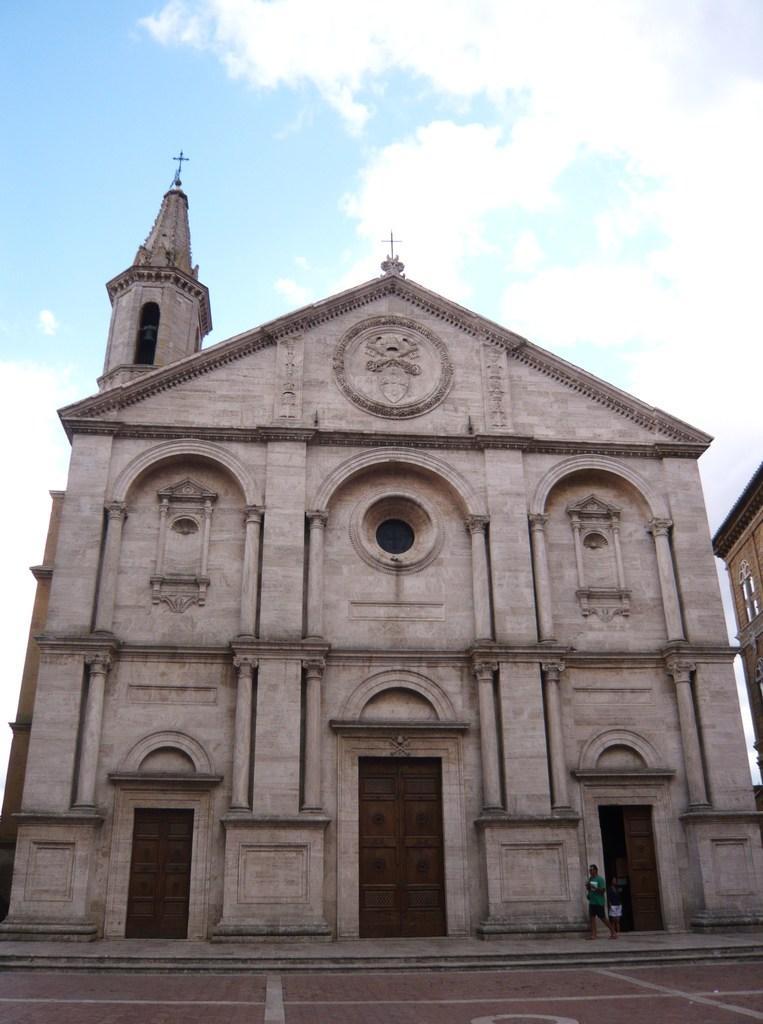How would you summarize this image in a sentence or two? In this image we can see a building, persons, door and some other objects. On the right side of the image it looks like a building. At the top of the image there is the sky. 